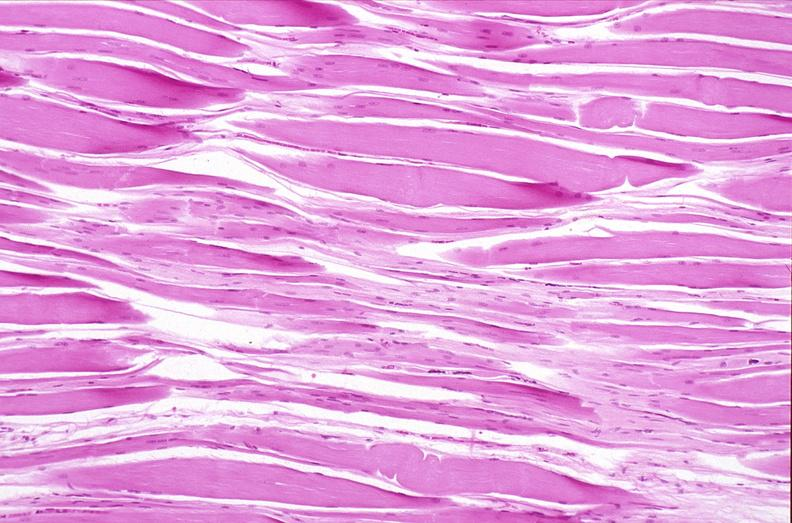why does this image show skeletal muscle, atrophy?
Answer the question using a single word or phrase. Due to immobilization cast 